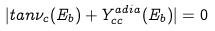<formula> <loc_0><loc_0><loc_500><loc_500>| t a n \nu _ { c } ( E _ { b } ) + Y ^ { a d i a } _ { c c } ( E _ { b } ) | = 0</formula> 